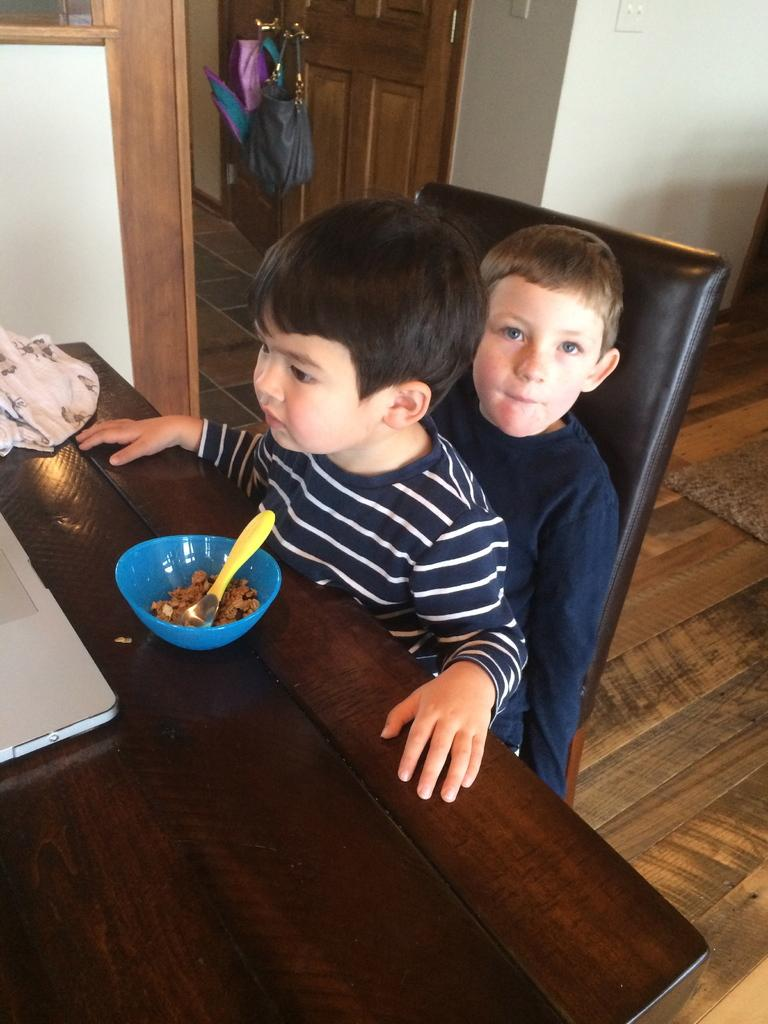How many kids are in the image? There are two kids in the image. What are the kids doing in the image? The kids are sitting on a chair. What is on the table in the image? There is a cloth, a bowl, and a spoon on the table. What is hanging over a door in the image? There are bags hanging over a door in the image. Can you tell me how many balloons are tied to the crib in the image? There is no crib present in the image, and therefore no balloons tied to it. What type of receipt is visible on the table in the image? There is no receipt visible on the table in the image. 